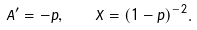<formula> <loc_0><loc_0><loc_500><loc_500>A ^ { \prime } = - p , \quad X = ( 1 - p ) ^ { - 2 } .</formula> 